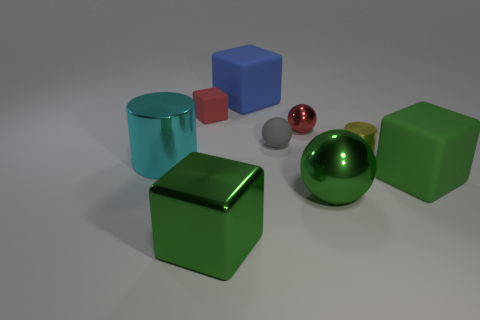Subtract 1 cubes. How many cubes are left? 3 Add 1 tiny metallic balls. How many objects exist? 10 Subtract all cylinders. How many objects are left? 7 Subtract all green matte cubes. Subtract all tiny metallic spheres. How many objects are left? 7 Add 9 blue rubber objects. How many blue rubber objects are left? 10 Add 3 small rubber things. How many small rubber things exist? 5 Subtract 0 blue balls. How many objects are left? 9 